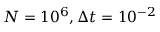<formula> <loc_0><loc_0><loc_500><loc_500>N = 1 0 ^ { 6 } , \Delta t = 1 0 ^ { - 2 }</formula> 